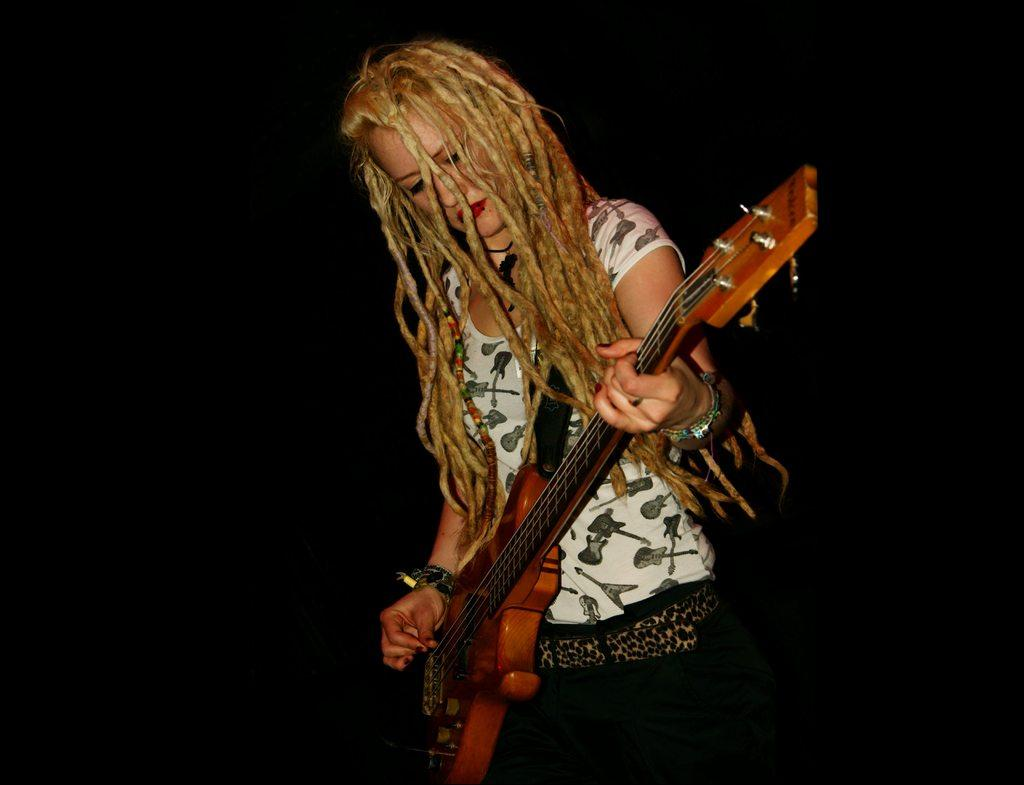Who is the main subject in the image? There is a woman in the image. What is the woman holding in the image? The woman is holding a guitar. What is the woman doing with the guitar? The woman is playing the guitar. What can be observed about the background of the image? The background of the image is dark. What type of jewel can be seen on the tree in the image? There is no tree or jewel present in the image. What color is the notebook on the woman's lap in the image? There is no notebook visible in the image; the woman is holding and playing a guitar. 